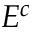Convert formula to latex. <formula><loc_0><loc_0><loc_500><loc_500>E ^ { c }</formula> 